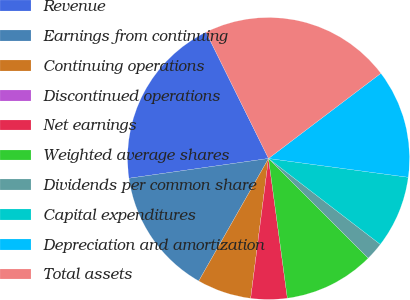<chart> <loc_0><loc_0><loc_500><loc_500><pie_chart><fcel>Revenue<fcel>Earnings from continuing<fcel>Continuing operations<fcel>Discontinued operations<fcel>Net earnings<fcel>Weighted average shares<fcel>Dividends per common share<fcel>Capital expenditures<fcel>Depreciation and amortization<fcel>Total assets<nl><fcel>19.92%<fcel>14.52%<fcel>6.22%<fcel>0.0%<fcel>4.15%<fcel>10.37%<fcel>2.07%<fcel>8.3%<fcel>12.45%<fcel>21.99%<nl></chart> 